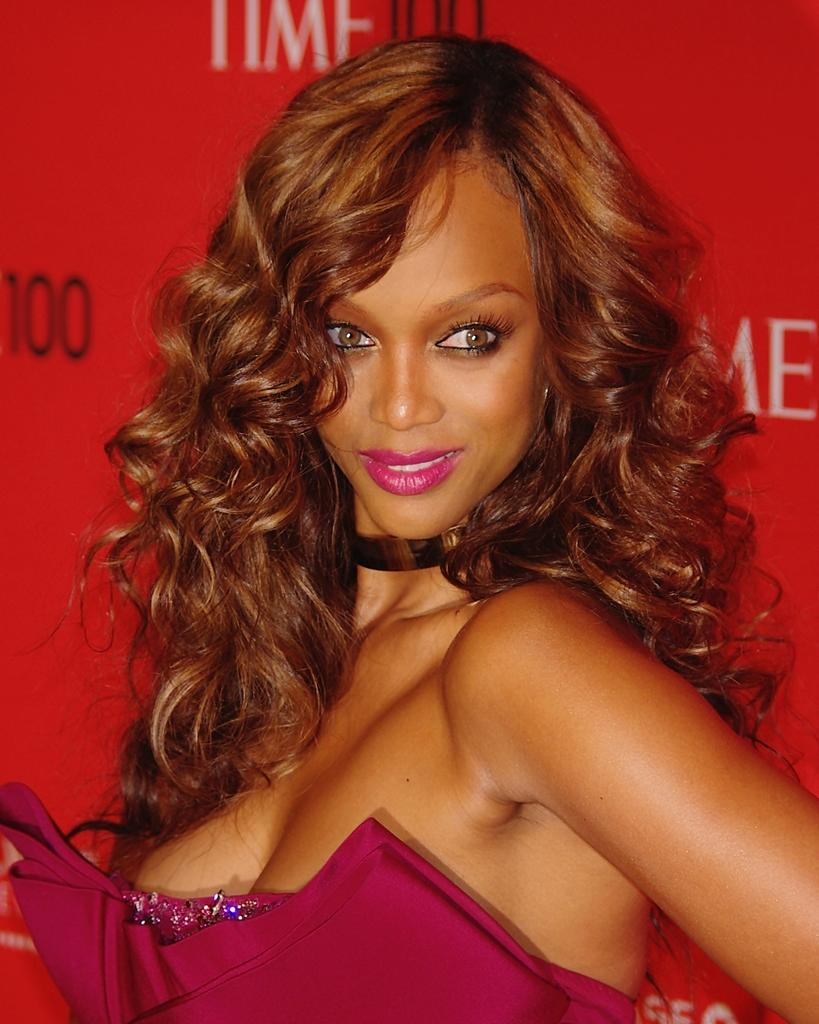Who is present in the image? There is a woman in the image. What is the woman doing in the image? The woman is standing and smiling. What can be seen in the background of the image? There is a board or banner with red color in the image, and there is text written on it. Can you tell me what type of dog is sitting next to the woman in the image? There is no dog present in the image; only the woman and the board or banner with text are visible. 